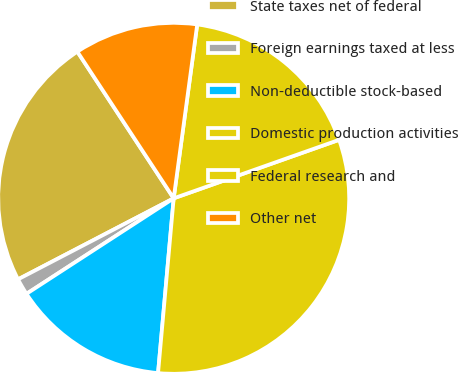<chart> <loc_0><loc_0><loc_500><loc_500><pie_chart><fcel>State taxes net of federal<fcel>Foreign earnings taxed at less<fcel>Non-deductible stock-based<fcel>Domestic production activities<fcel>Federal research and<fcel>Other net<nl><fcel>23.39%<fcel>1.52%<fcel>14.42%<fcel>31.83%<fcel>17.45%<fcel>11.39%<nl></chart> 